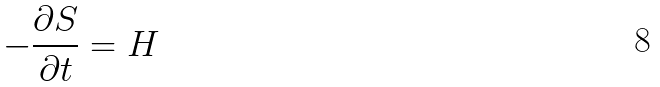<formula> <loc_0><loc_0><loc_500><loc_500>- \frac { \partial S } { \partial t } = H</formula> 